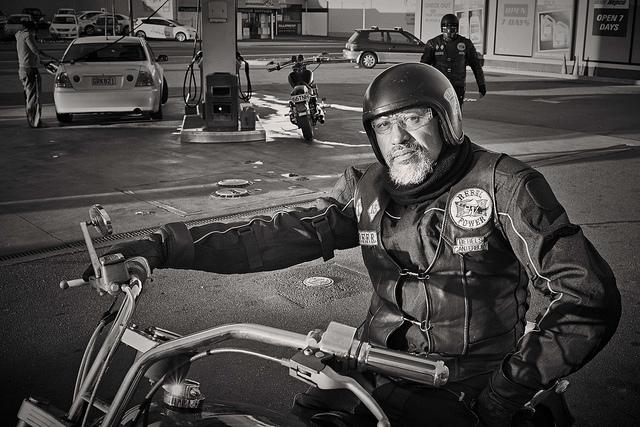What is the person with the white car doing?
Give a very brief answer. Pumping gas. What is the guy sitting on?
Answer briefly. Motorcycle. What color is the jacket?
Quick response, please. Black. How many mirrors are on the motorcycle?
Give a very brief answer. 1. What is this man sitting on?
Be succinct. Motorcycle. Is there more than one car visible?
Concise answer only. Yes. Is the rider watching the road?
Be succinct. No. Is this a commercial?
Keep it brief. No. 